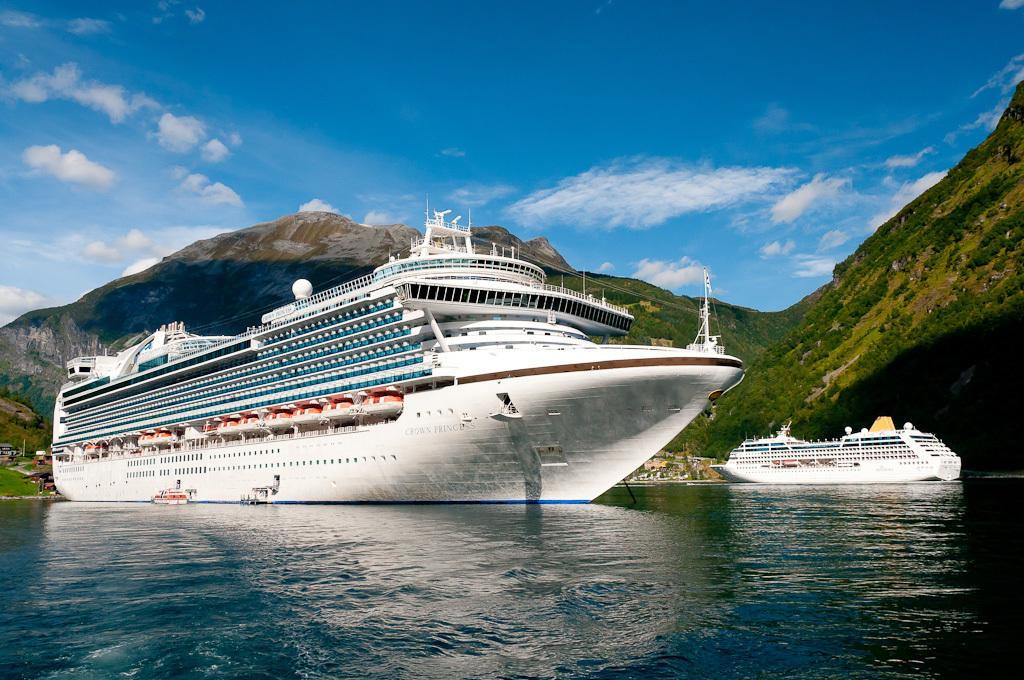What can be seen in the image related to transportation? There are two ships in the image. Where are the ships located? The ships are on water. What type of natural landscape is visible in the image? There are mountains visible in the image. What is visible in the background of the image? The sky is visible in the background of the image. What can be observed in the sky? Clouds are present in the sky. What type of scissors can be seen cutting through the clouds in the image? There are no scissors present in the image, and the clouds are not being cut. 